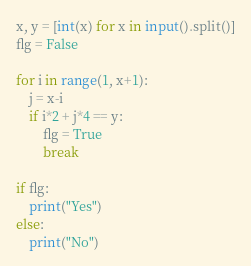<code> <loc_0><loc_0><loc_500><loc_500><_Python_>x, y = [int(x) for x in input().split()]
flg = False

for i in range(1, x+1):
    j = x-i
    if i*2 + j*4 == y:
        flg = True
        break

if flg:
    print("Yes")
else:
    print("No")
</code> 